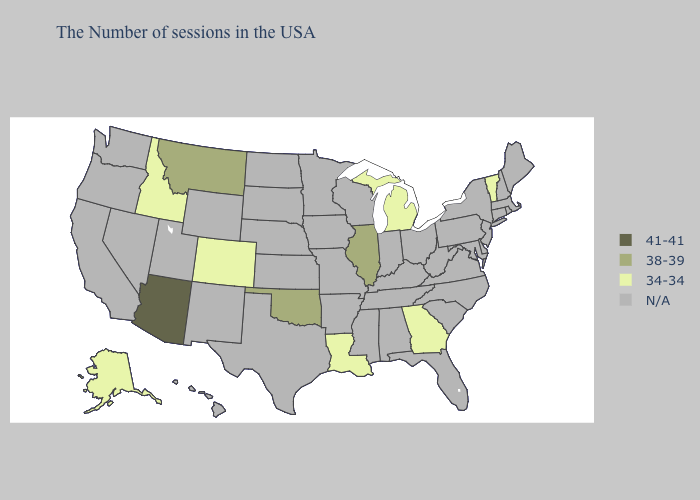Name the states that have a value in the range 34-34?
Keep it brief. Vermont, Georgia, Michigan, Louisiana, Colorado, Idaho, Alaska. Does Montana have the lowest value in the West?
Write a very short answer. No. What is the lowest value in the USA?
Keep it brief. 34-34. What is the value of Utah?
Answer briefly. N/A. How many symbols are there in the legend?
Give a very brief answer. 4. Does Arizona have the lowest value in the USA?
Keep it brief. No. What is the highest value in the West ?
Be succinct. 41-41. Does the first symbol in the legend represent the smallest category?
Give a very brief answer. No. What is the value of Florida?
Write a very short answer. N/A. Name the states that have a value in the range N/A?
Be succinct. Maine, Massachusetts, Rhode Island, New Hampshire, Connecticut, New York, New Jersey, Delaware, Maryland, Pennsylvania, Virginia, North Carolina, South Carolina, West Virginia, Ohio, Florida, Kentucky, Indiana, Alabama, Tennessee, Wisconsin, Mississippi, Missouri, Arkansas, Minnesota, Iowa, Kansas, Nebraska, Texas, South Dakota, North Dakota, Wyoming, New Mexico, Utah, Nevada, California, Washington, Oregon, Hawaii. What is the value of Illinois?
Quick response, please. 38-39. How many symbols are there in the legend?
Be succinct. 4. 